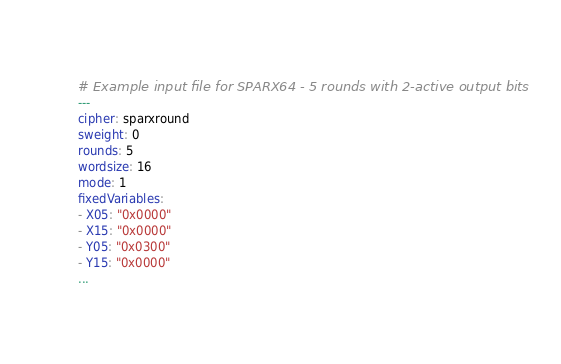<code> <loc_0><loc_0><loc_500><loc_500><_YAML_># Example input file for SPARX64 - 5 rounds with 2-active output bits
---
cipher: sparxround
sweight: 0
rounds: 5
wordsize: 16
mode: 1
fixedVariables:
- X05: "0x0000"
- X15: "0x0000"
- Y05: "0x0300"
- Y15: "0x0000"
...

</code> 